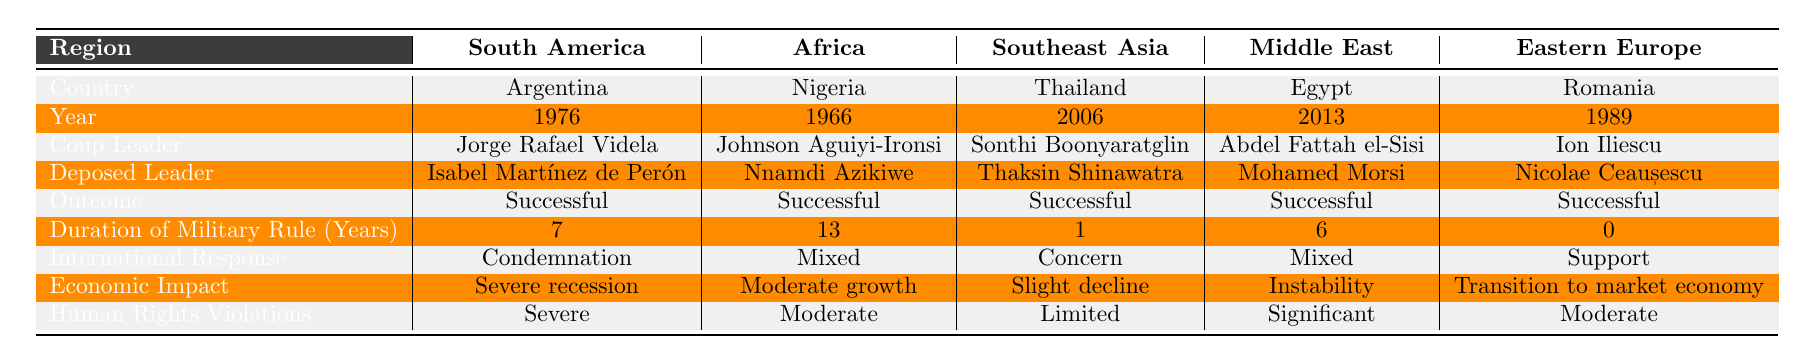What is the year of the coup in Thailand? The table directly indicates that the coup in Thailand occurred in the year 2006.
Answer: 2006 Which country had a successful coup with the least duration of military rule? Looking at the "Duration of Military Rule (Years)" column, Thailand had a duration of 1 year, which is the shortest among the successful coups listed.
Answer: Thailand What was the international response to the coup in Egypt? The table shows that the international response to the coup in Egypt was classified as "Mixed".
Answer: Mixed How many countries listed had a coup outcome that was labeled successful? All five countries—Argentina, Nigeria, Thailand, Egypt, and Romania—had a coup outcome that was successful, as indicated in the "Outcome" column.
Answer: 5 Which region had a leader named Ion Iliescu who led a successful coup? The table reveals that Ion Iliescu led a coup in Romania, which is part of Eastern Europe.
Answer: Eastern Europe What two countries experienced significant human rights violations following their coups? The table lists Egypt with "Significant" and Argentina with "Severe" human rights violations as outcomes of their coups.
Answer: Argentina and Egypt What is the average duration of military rule for the coups listed in the table? By adding the durations (7 + 13 + 1 + 6 + 0) = 27 and dividing by the number of countries (5), the average duration of military rule is 27 / 5 = 5.4 years.
Answer: 5.4 years Is there a country listed that had a coup outcome classified as unsuccessful? The table indicates that all coups listed had a successful outcome, meaning there are no unsuccessful coups present.
Answer: No What economic impact did Nigeria's coup have? The economic impact of Nigeria's coup is categorized as "Moderate growth" in the table.
Answer: Moderate growth Which coup leader rose to power in 2013? The table indicates that Abdel Fattah el-Sisi was the coup leader who rose to power in Egypt in 2013.
Answer: Abdel Fattah el-Sisi 